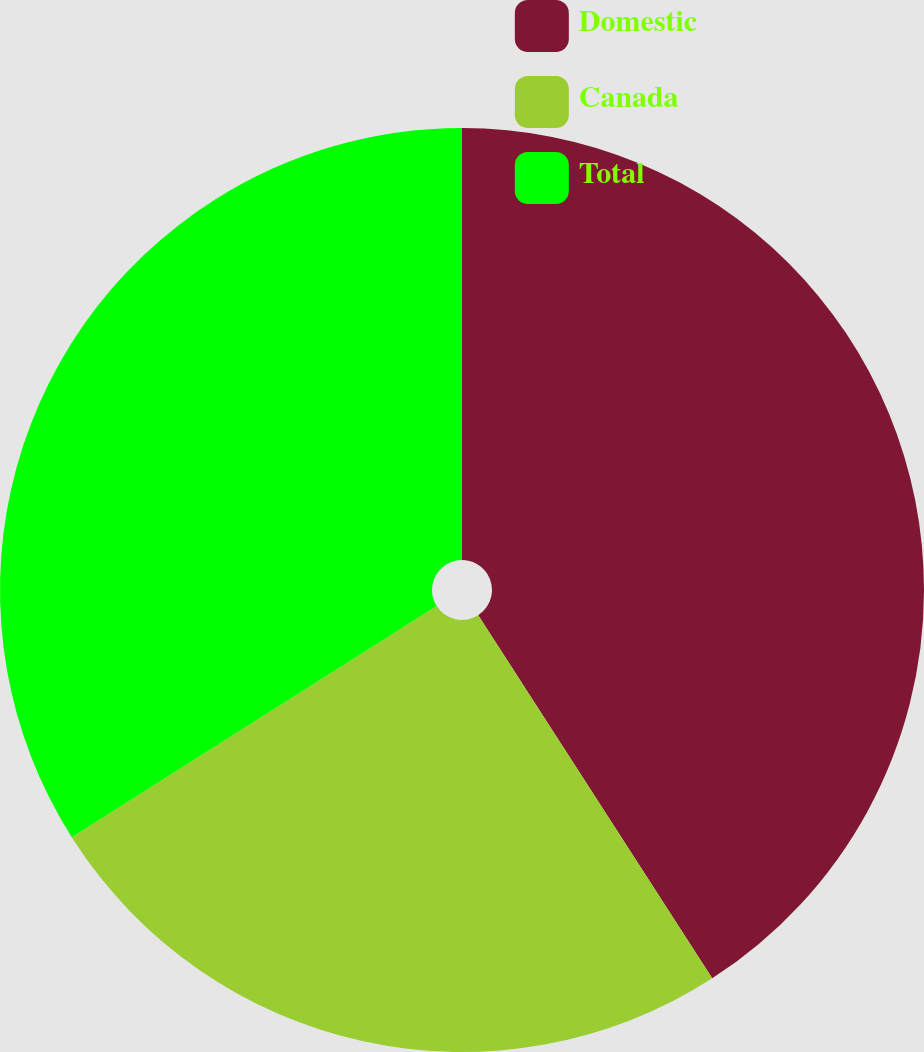<chart> <loc_0><loc_0><loc_500><loc_500><pie_chart><fcel>Domestic<fcel>Canada<fcel>Total<nl><fcel>40.89%<fcel>25.12%<fcel>33.99%<nl></chart> 